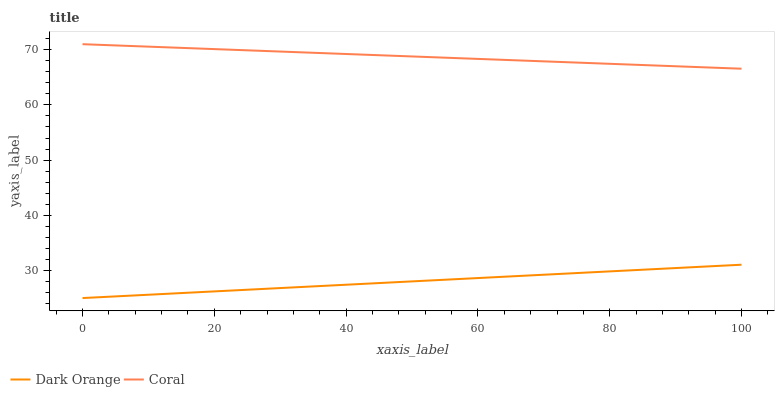Does Dark Orange have the minimum area under the curve?
Answer yes or no. Yes. Does Coral have the maximum area under the curve?
Answer yes or no. Yes. Does Coral have the minimum area under the curve?
Answer yes or no. No. Is Dark Orange the smoothest?
Answer yes or no. Yes. Is Coral the roughest?
Answer yes or no. Yes. Is Coral the smoothest?
Answer yes or no. No. Does Dark Orange have the lowest value?
Answer yes or no. Yes. Does Coral have the lowest value?
Answer yes or no. No. Does Coral have the highest value?
Answer yes or no. Yes. Is Dark Orange less than Coral?
Answer yes or no. Yes. Is Coral greater than Dark Orange?
Answer yes or no. Yes. Does Dark Orange intersect Coral?
Answer yes or no. No. 